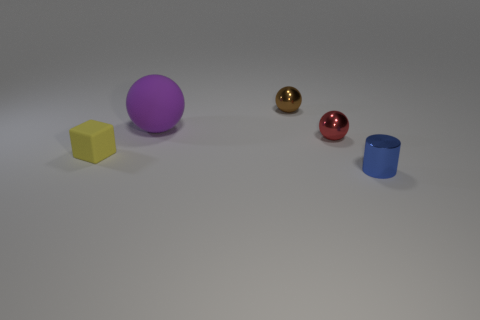Add 4 brown objects. How many objects exist? 9 Subtract all blocks. How many objects are left? 4 Subtract all red cylinders. Subtract all tiny red objects. How many objects are left? 4 Add 2 purple matte balls. How many purple matte balls are left? 3 Add 1 metallic cylinders. How many metallic cylinders exist? 2 Subtract 0 purple cubes. How many objects are left? 5 